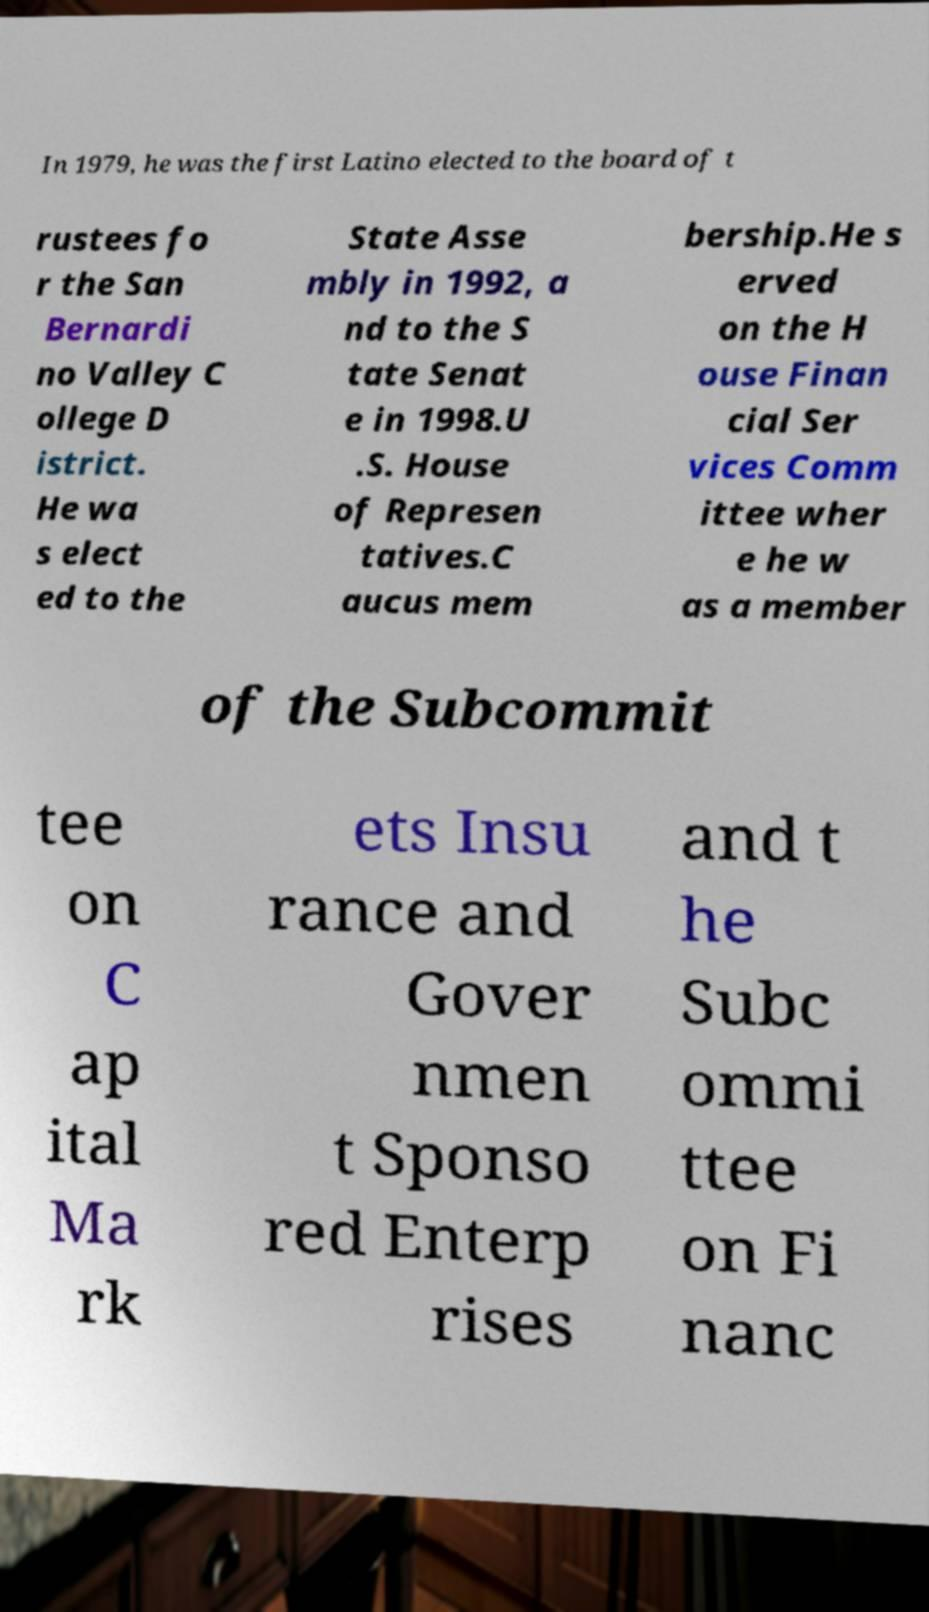I need the written content from this picture converted into text. Can you do that? In 1979, he was the first Latino elected to the board of t rustees fo r the San Bernardi no Valley C ollege D istrict. He wa s elect ed to the State Asse mbly in 1992, a nd to the S tate Senat e in 1998.U .S. House of Represen tatives.C aucus mem bership.He s erved on the H ouse Finan cial Ser vices Comm ittee wher e he w as a member of the Subcommit tee on C ap ital Ma rk ets Insu rance and Gover nmen t Sponso red Enterp rises and t he Subc ommi ttee on Fi nanc 